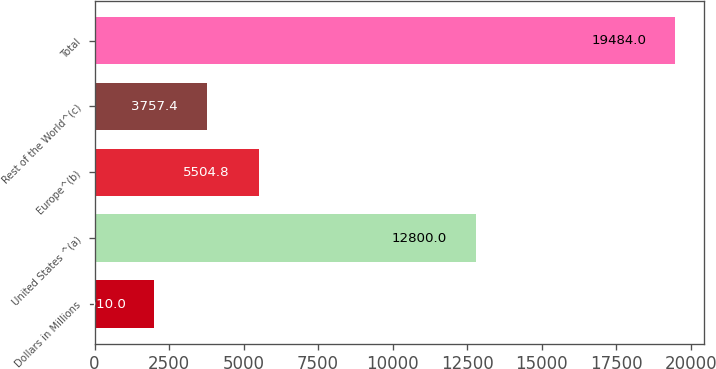Convert chart to OTSL. <chart><loc_0><loc_0><loc_500><loc_500><bar_chart><fcel>Dollars in Millions<fcel>United States ^(a)<fcel>Europe^(b)<fcel>Rest of the World^(c)<fcel>Total<nl><fcel>2010<fcel>12800<fcel>5504.8<fcel>3757.4<fcel>19484<nl></chart> 